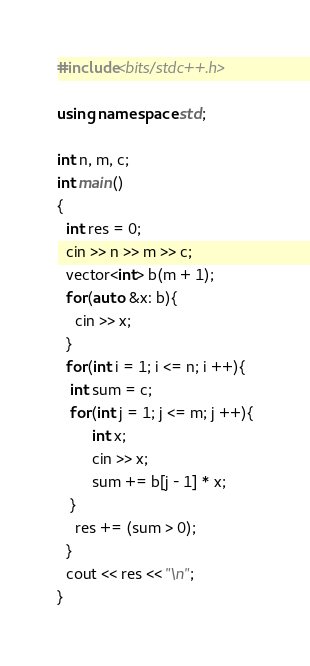<code> <loc_0><loc_0><loc_500><loc_500><_C++_>#include<bits/stdc++.h>

using namespace std;

int n, m, c;
int main()
{
  int res = 0;
  cin >> n >> m >> c;
  vector<int> b(m + 1);
  for(auto &x: b){
    cin >> x;
  }
  for(int i = 1; i <= n; i ++){
   int sum = c;
   for(int j = 1; j <= m; j ++){
   		int x;
    	cin >> x;
     	sum += b[j - 1] * x;
   }
    res += (sum > 0);
  }
  cout << res << "\n";
}</code> 